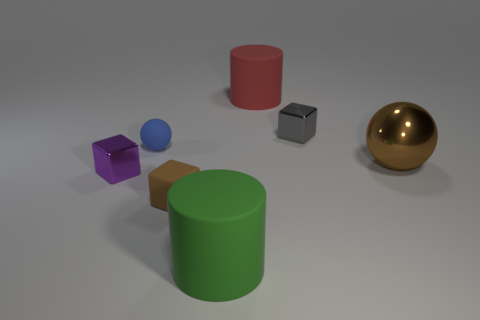Are there any other things that have the same size as the blue object?
Make the answer very short. Yes. How many big yellow cubes are there?
Make the answer very short. 0. There is a blue rubber thing; what number of small cubes are on the right side of it?
Your answer should be very brief. 2. Do the purple cube and the big brown thing have the same material?
Offer a terse response. Yes. How many things are both in front of the small rubber sphere and on the left side of the small brown thing?
Your answer should be compact. 1. What number of other things are there of the same color as the small rubber sphere?
Provide a succinct answer. 0. How many red things are small matte blocks or metallic balls?
Offer a very short reply. 0. The green cylinder is what size?
Your response must be concise. Large. What number of metal things are small blue objects or large red balls?
Give a very brief answer. 0. Is the number of yellow cubes less than the number of big metal spheres?
Your answer should be very brief. Yes. 